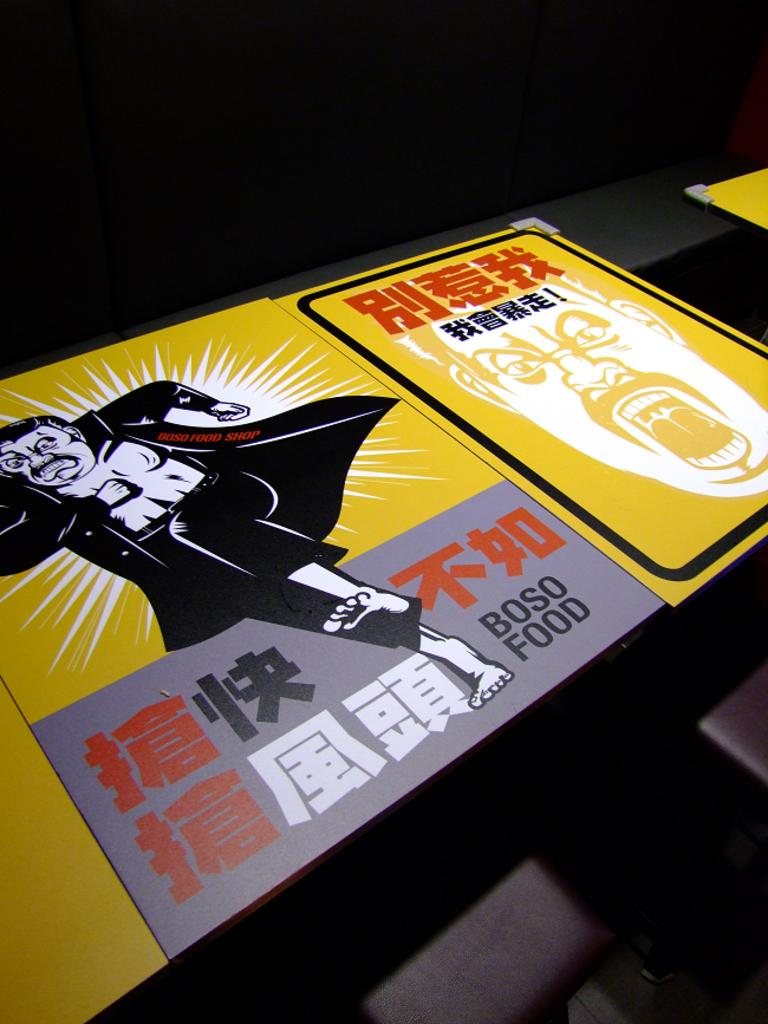<image>
Give a short and clear explanation of the subsequent image. The Asian worded ad is promoting Boso Foods. 